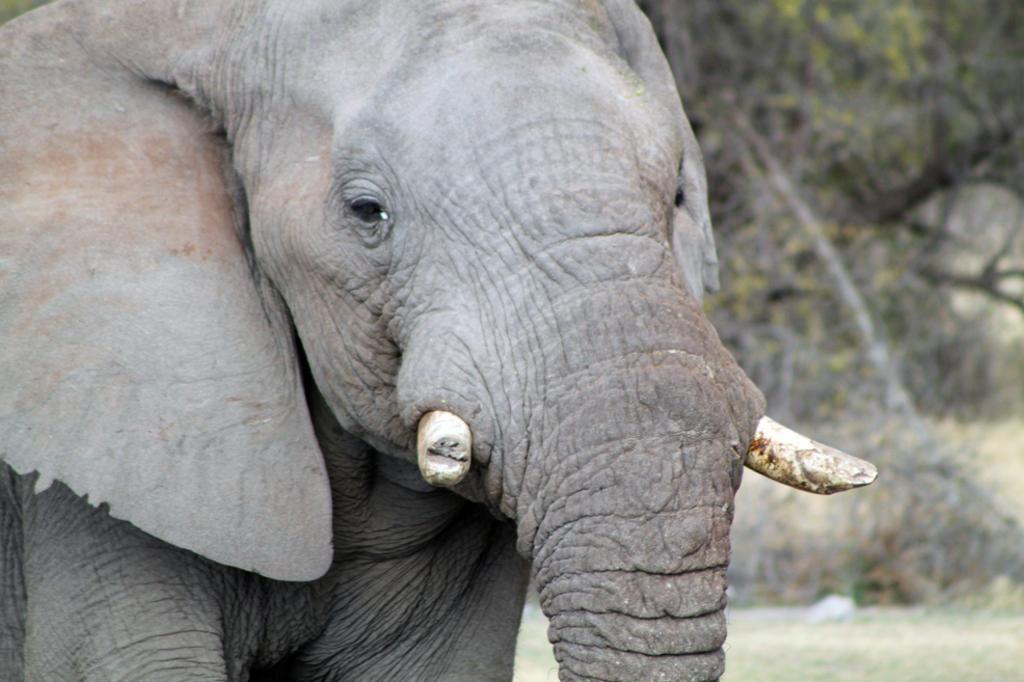Could you give a brief overview of what you see in this image? The picture consists of an elephant. The background is blurred. In the background there are trees, plants and grass. 